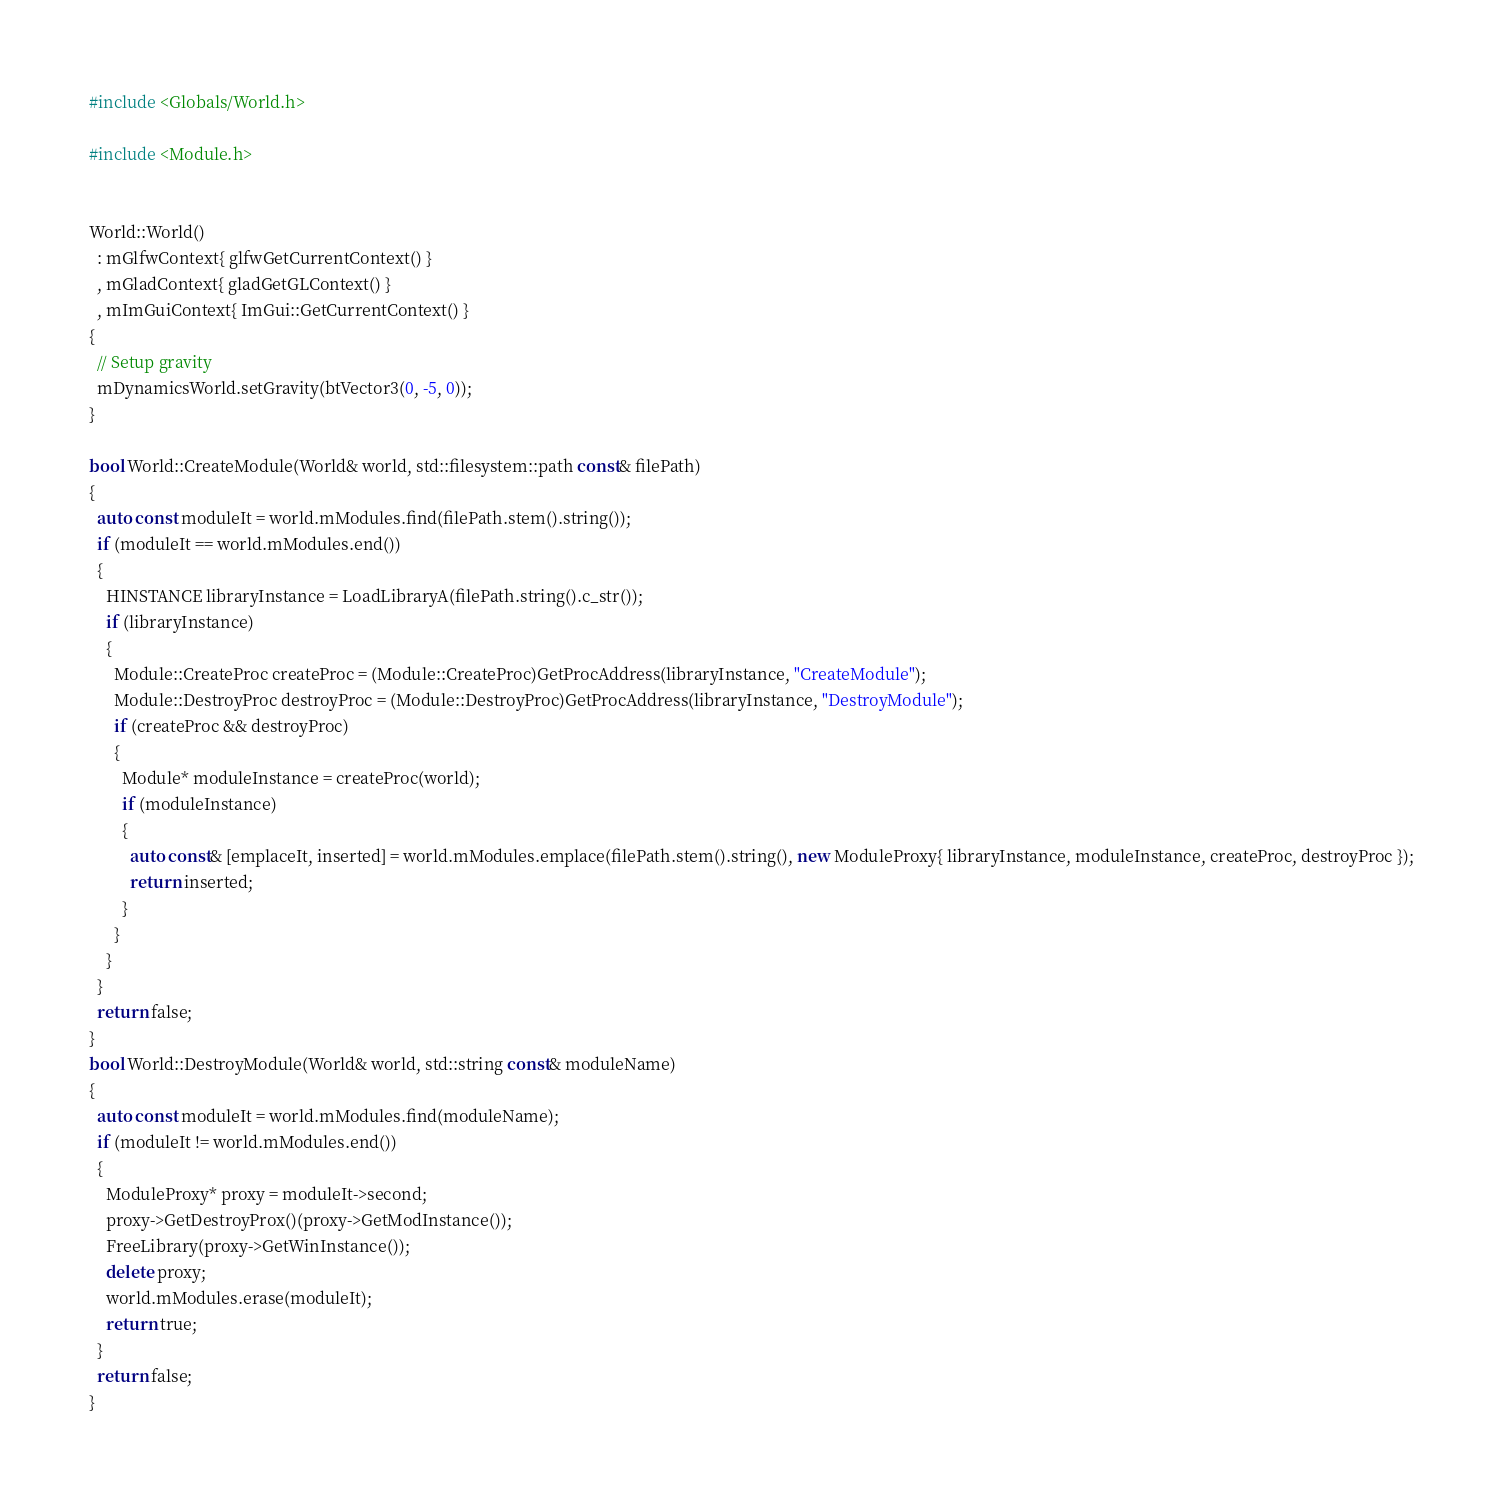<code> <loc_0><loc_0><loc_500><loc_500><_C++_>#include <Globals/World.h>

#include <Module.h>


World::World()
  : mGlfwContext{ glfwGetCurrentContext() }
  , mGladContext{ gladGetGLContext() }
  , mImGuiContext{ ImGui::GetCurrentContext() }
{
  // Setup gravity
  mDynamicsWorld.setGravity(btVector3(0, -5, 0));
}

bool World::CreateModule(World& world, std::filesystem::path const& filePath)
{
  auto const moduleIt = world.mModules.find(filePath.stem().string());
  if (moduleIt == world.mModules.end())
  {
    HINSTANCE libraryInstance = LoadLibraryA(filePath.string().c_str());
    if (libraryInstance)
    {
      Module::CreateProc createProc = (Module::CreateProc)GetProcAddress(libraryInstance, "CreateModule");
      Module::DestroyProc destroyProc = (Module::DestroyProc)GetProcAddress(libraryInstance, "DestroyModule");
      if (createProc && destroyProc)
      {
        Module* moduleInstance = createProc(world);
        if (moduleInstance)
        {
          auto const& [emplaceIt, inserted] = world.mModules.emplace(filePath.stem().string(), new ModuleProxy{ libraryInstance, moduleInstance, createProc, destroyProc });
          return inserted;
        }
      }
    }
  }
  return false;
}
bool World::DestroyModule(World& world, std::string const& moduleName)
{
  auto const moduleIt = world.mModules.find(moduleName);
  if (moduleIt != world.mModules.end())
  {
    ModuleProxy* proxy = moduleIt->second;
    proxy->GetDestroyProx()(proxy->GetModInstance());
    FreeLibrary(proxy->GetWinInstance());
    delete proxy;
    world.mModules.erase(moduleIt);
    return true;
  }
  return false;
}</code> 